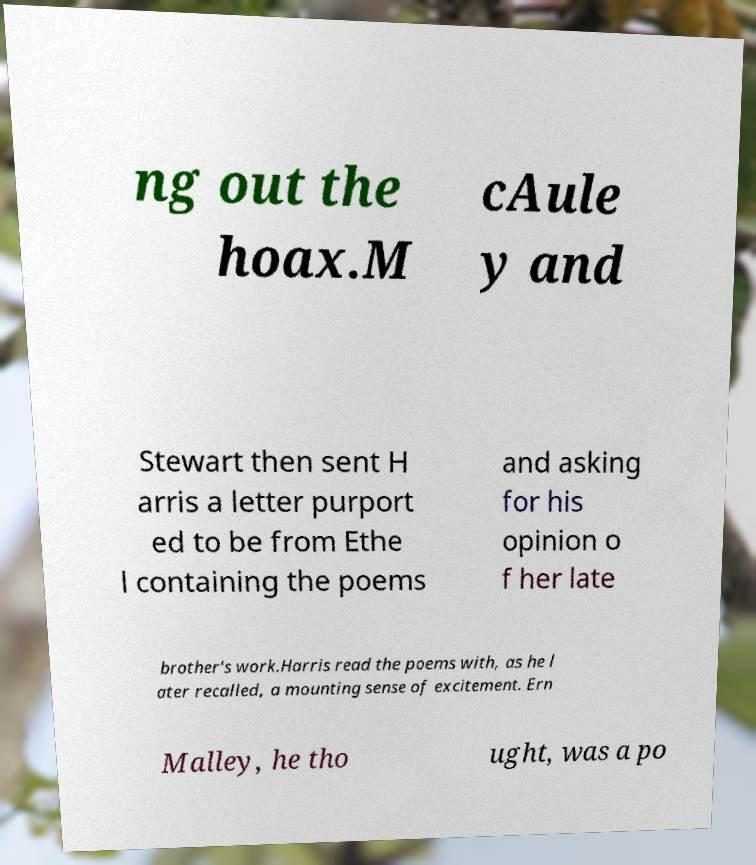For documentation purposes, I need the text within this image transcribed. Could you provide that? ng out the hoax.M cAule y and Stewart then sent H arris a letter purport ed to be from Ethe l containing the poems and asking for his opinion o f her late brother's work.Harris read the poems with, as he l ater recalled, a mounting sense of excitement. Ern Malley, he tho ught, was a po 